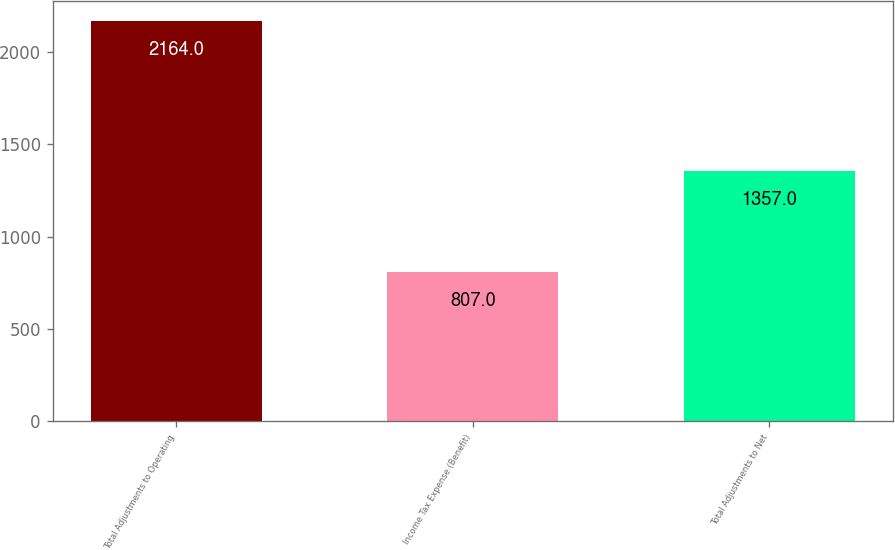Convert chart. <chart><loc_0><loc_0><loc_500><loc_500><bar_chart><fcel>Total Adjustments to Operating<fcel>Income Tax Expense (Benefit)<fcel>Total Adjustments to Net<nl><fcel>2164<fcel>807<fcel>1357<nl></chart> 